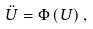<formula> <loc_0><loc_0><loc_500><loc_500>\ddot { U } = \Phi \left ( U \right ) ,</formula> 